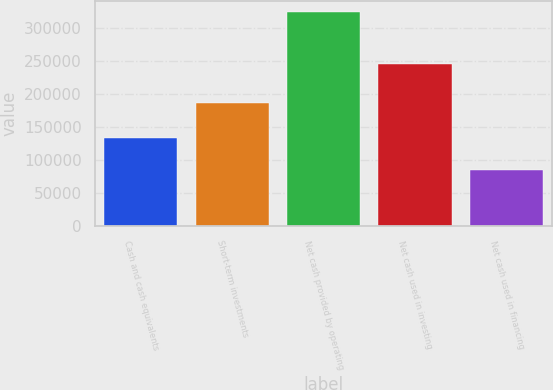<chart> <loc_0><loc_0><loc_500><loc_500><bar_chart><fcel>Cash and cash equivalents<fcel>Short-term investments<fcel>Net cash provided by operating<fcel>Net cash used in investing<fcel>Net cash used in financing<nl><fcel>134224<fcel>186018<fcel>325063<fcel>246079<fcel>84641<nl></chart> 